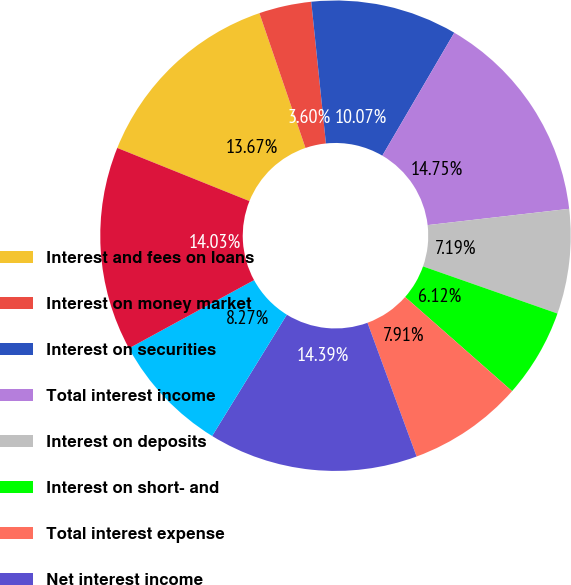Convert chart. <chart><loc_0><loc_0><loc_500><loc_500><pie_chart><fcel>Interest and fees on loans<fcel>Interest on money market<fcel>Interest on securities<fcel>Total interest income<fcel>Interest on deposits<fcel>Interest on short- and<fcel>Total interest expense<fcel>Net interest income<fcel>Provision for loan losses<fcel>Net interest income after<nl><fcel>13.67%<fcel>3.6%<fcel>10.07%<fcel>14.75%<fcel>7.19%<fcel>6.12%<fcel>7.91%<fcel>14.39%<fcel>8.27%<fcel>14.03%<nl></chart> 